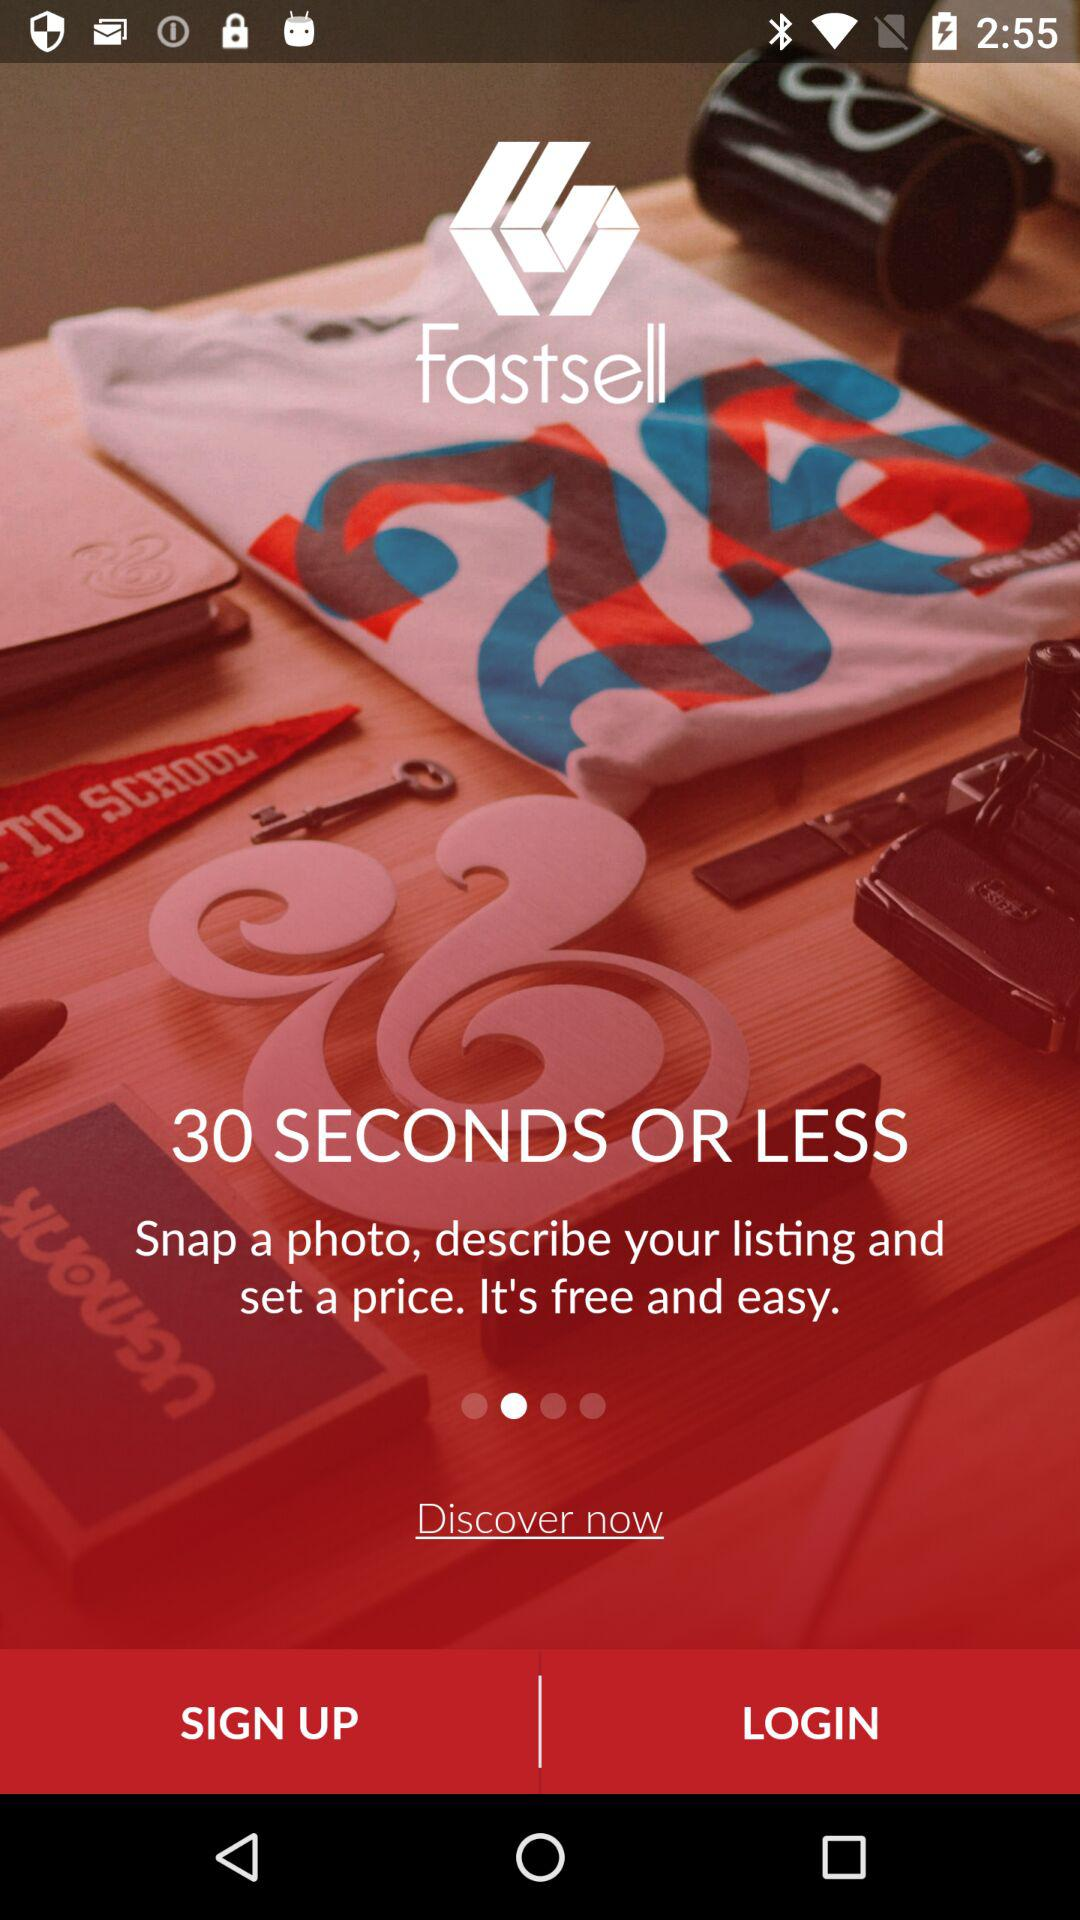Within how many seconds can I sell? You can sell within 30 seconds or less. 